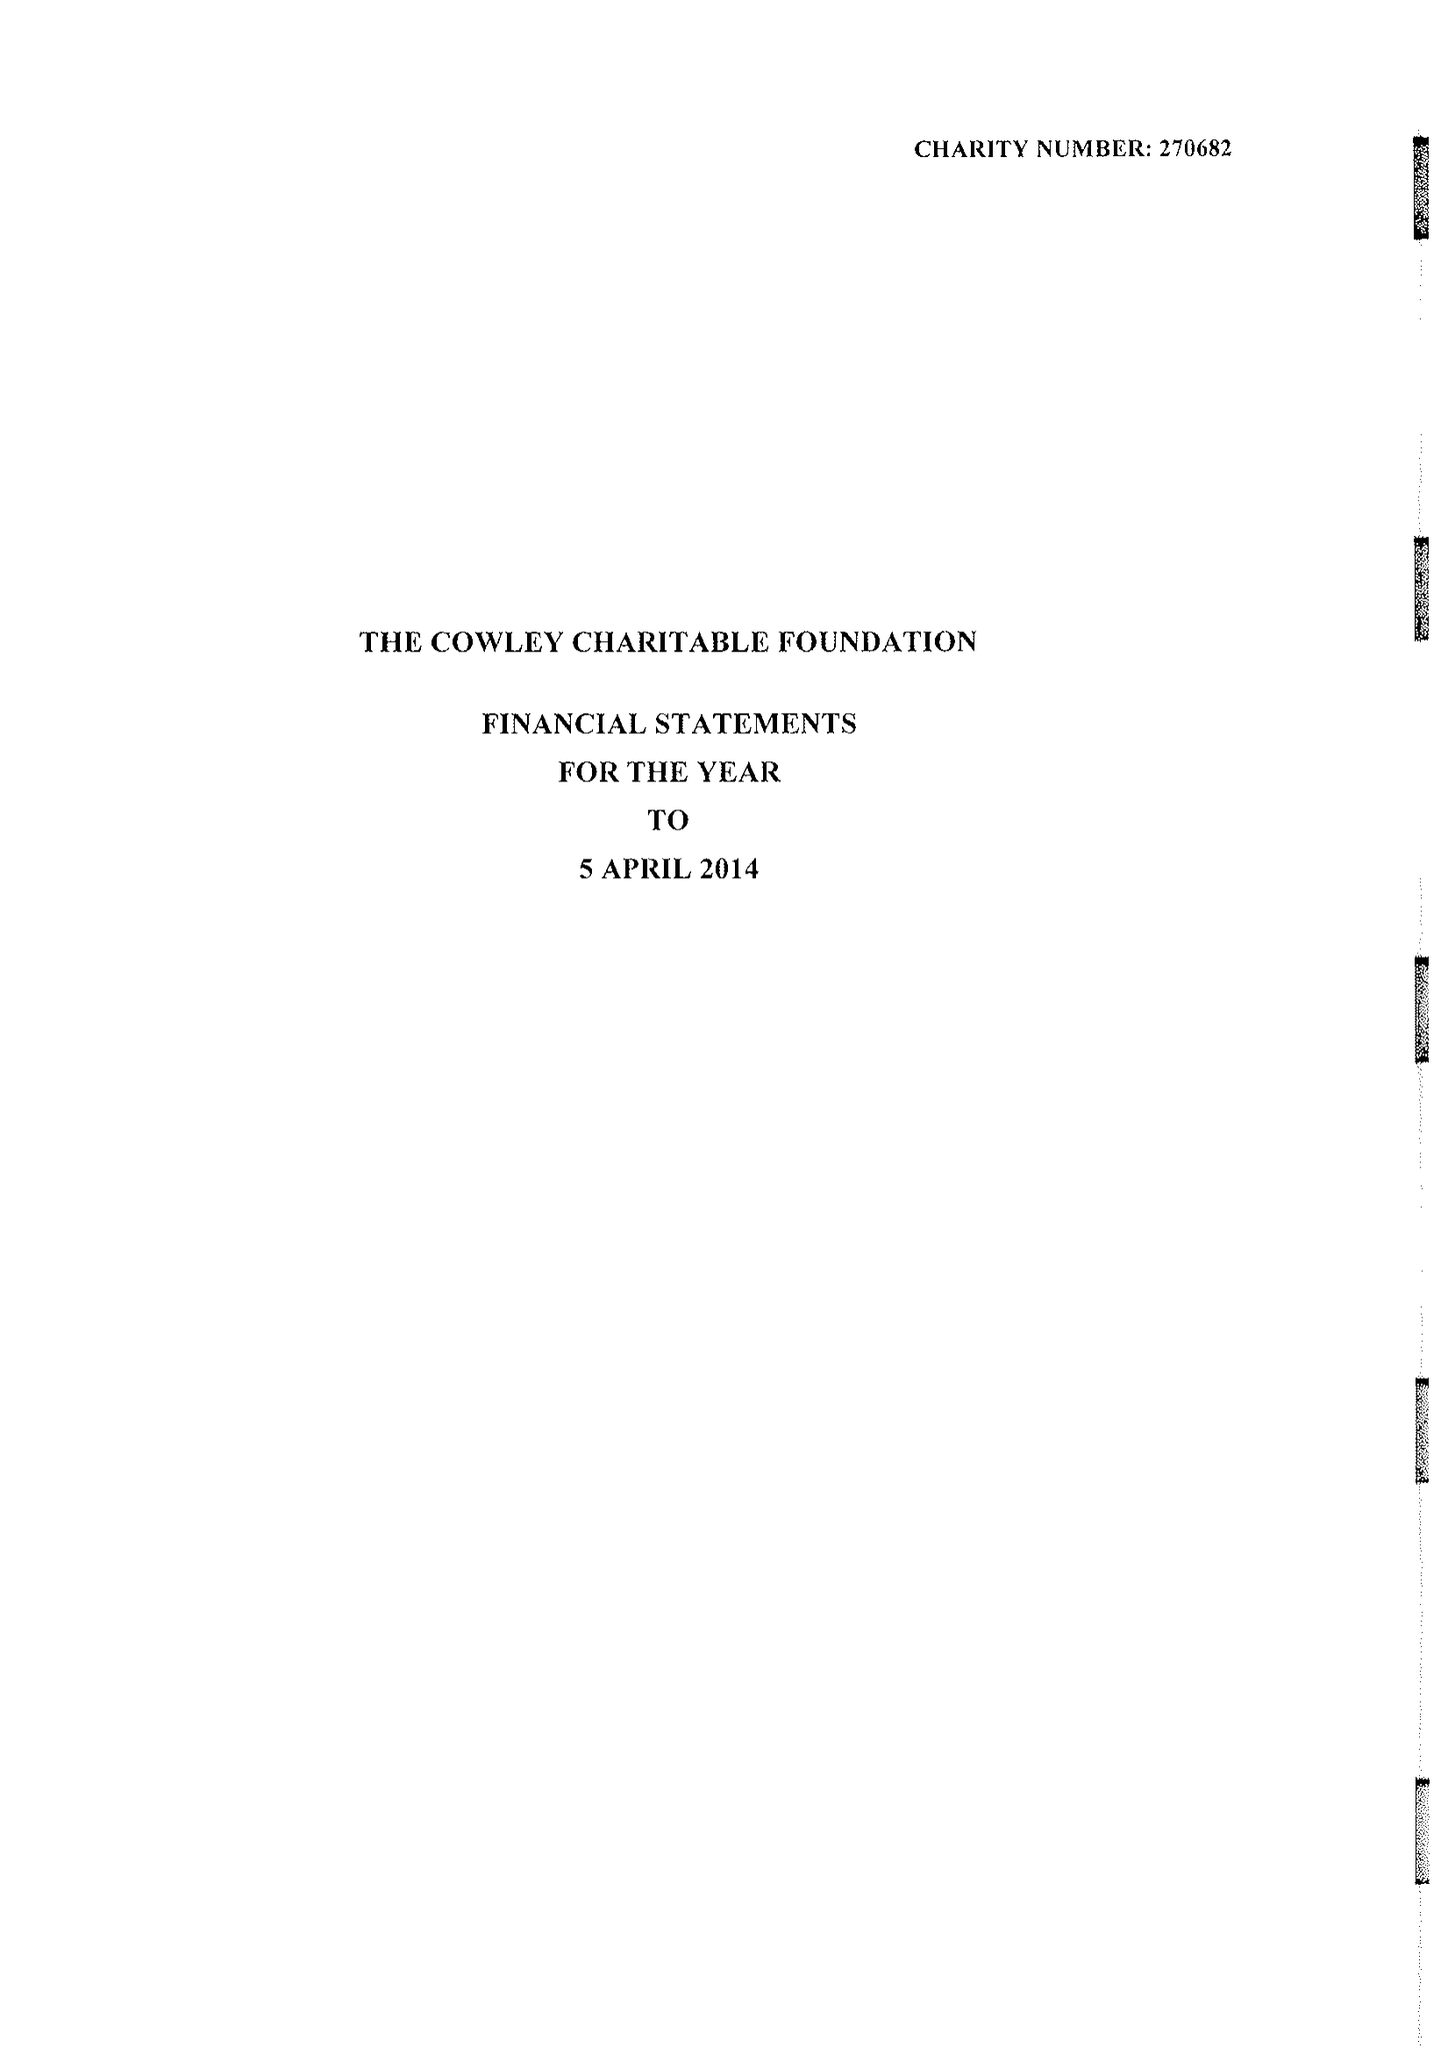What is the value for the income_annually_in_british_pounds?
Answer the question using a single word or phrase. 33990.00 